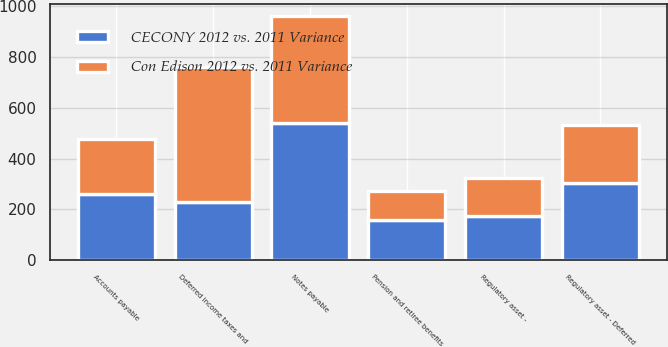<chart> <loc_0><loc_0><loc_500><loc_500><stacked_bar_chart><ecel><fcel>Regulatory asset - Deferred<fcel>Regulatory asset -<fcel>Deferred income taxes and<fcel>Notes payable<fcel>Accounts payable<fcel>Pension and retiree benefits<nl><fcel>CECONY 2012 vs. 2011 Variance<fcel>304<fcel>175<fcel>229<fcel>539<fcel>260<fcel>157<nl><fcel>Con Edison 2012 vs. 2011 Variance<fcel>229<fcel>147<fcel>531<fcel>421<fcel>215<fcel>117<nl></chart> 